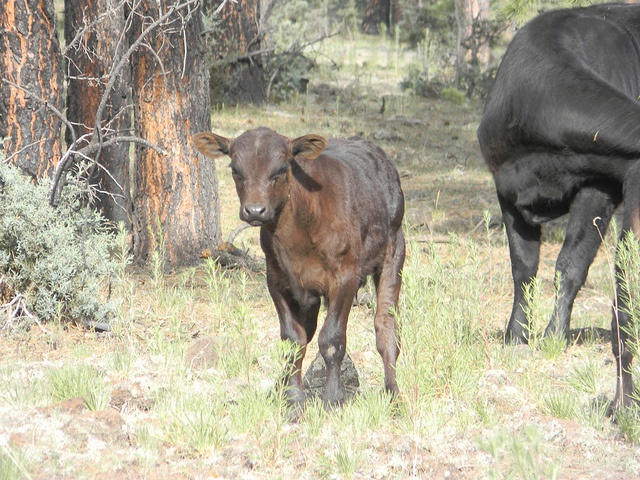Describe the objects in this image and their specific colors. I can see cow in gray, black, darkgray, and khaki tones and cow in gray and darkgray tones in this image. 